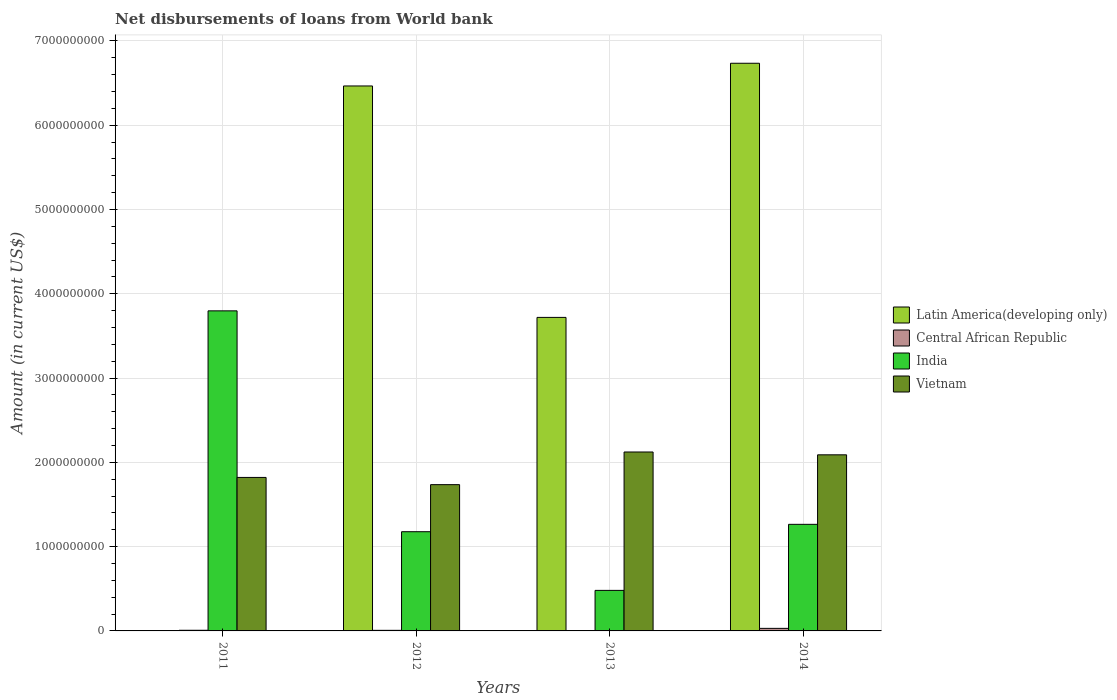How many different coloured bars are there?
Offer a very short reply. 4. How many groups of bars are there?
Make the answer very short. 4. Are the number of bars per tick equal to the number of legend labels?
Provide a short and direct response. No. Are the number of bars on each tick of the X-axis equal?
Provide a short and direct response. No. How many bars are there on the 3rd tick from the left?
Provide a short and direct response. 3. What is the label of the 3rd group of bars from the left?
Provide a succinct answer. 2013. In how many cases, is the number of bars for a given year not equal to the number of legend labels?
Offer a terse response. 2. What is the amount of loan disbursed from World Bank in Vietnam in 2013?
Make the answer very short. 2.12e+09. Across all years, what is the maximum amount of loan disbursed from World Bank in India?
Offer a very short reply. 3.80e+09. Across all years, what is the minimum amount of loan disbursed from World Bank in Central African Republic?
Ensure brevity in your answer.  0. In which year was the amount of loan disbursed from World Bank in Central African Republic maximum?
Ensure brevity in your answer.  2014. What is the total amount of loan disbursed from World Bank in Latin America(developing only) in the graph?
Your answer should be compact. 1.69e+1. What is the difference between the amount of loan disbursed from World Bank in India in 2011 and that in 2013?
Keep it short and to the point. 3.32e+09. What is the difference between the amount of loan disbursed from World Bank in Vietnam in 2014 and the amount of loan disbursed from World Bank in India in 2013?
Make the answer very short. 1.61e+09. What is the average amount of loan disbursed from World Bank in India per year?
Provide a short and direct response. 1.68e+09. In the year 2013, what is the difference between the amount of loan disbursed from World Bank in India and amount of loan disbursed from World Bank in Latin America(developing only)?
Keep it short and to the point. -3.24e+09. What is the ratio of the amount of loan disbursed from World Bank in Latin America(developing only) in 2013 to that in 2014?
Your answer should be very brief. 0.55. What is the difference between the highest and the second highest amount of loan disbursed from World Bank in India?
Make the answer very short. 2.53e+09. What is the difference between the highest and the lowest amount of loan disbursed from World Bank in Central African Republic?
Provide a succinct answer. 3.04e+07. Is the sum of the amount of loan disbursed from World Bank in Central African Republic in 2011 and 2012 greater than the maximum amount of loan disbursed from World Bank in Latin America(developing only) across all years?
Keep it short and to the point. No. Is it the case that in every year, the sum of the amount of loan disbursed from World Bank in Vietnam and amount of loan disbursed from World Bank in Latin America(developing only) is greater than the amount of loan disbursed from World Bank in Central African Republic?
Keep it short and to the point. Yes. How many bars are there?
Ensure brevity in your answer.  14. How many years are there in the graph?
Your answer should be very brief. 4. What is the difference between two consecutive major ticks on the Y-axis?
Offer a terse response. 1.00e+09. How are the legend labels stacked?
Your response must be concise. Vertical. What is the title of the graph?
Make the answer very short. Net disbursements of loans from World bank. Does "Uganda" appear as one of the legend labels in the graph?
Make the answer very short. No. What is the Amount (in current US$) of Central African Republic in 2011?
Provide a short and direct response. 7.68e+06. What is the Amount (in current US$) in India in 2011?
Make the answer very short. 3.80e+09. What is the Amount (in current US$) of Vietnam in 2011?
Your answer should be very brief. 1.82e+09. What is the Amount (in current US$) in Latin America(developing only) in 2012?
Provide a succinct answer. 6.47e+09. What is the Amount (in current US$) in Central African Republic in 2012?
Give a very brief answer. 7.00e+06. What is the Amount (in current US$) in India in 2012?
Provide a succinct answer. 1.18e+09. What is the Amount (in current US$) of Vietnam in 2012?
Provide a short and direct response. 1.74e+09. What is the Amount (in current US$) in Latin America(developing only) in 2013?
Your answer should be very brief. 3.72e+09. What is the Amount (in current US$) in India in 2013?
Offer a terse response. 4.81e+08. What is the Amount (in current US$) of Vietnam in 2013?
Your answer should be compact. 2.12e+09. What is the Amount (in current US$) in Latin America(developing only) in 2014?
Make the answer very short. 6.74e+09. What is the Amount (in current US$) of Central African Republic in 2014?
Offer a terse response. 3.04e+07. What is the Amount (in current US$) in India in 2014?
Keep it short and to the point. 1.26e+09. What is the Amount (in current US$) of Vietnam in 2014?
Provide a succinct answer. 2.09e+09. Across all years, what is the maximum Amount (in current US$) in Latin America(developing only)?
Provide a succinct answer. 6.74e+09. Across all years, what is the maximum Amount (in current US$) in Central African Republic?
Provide a short and direct response. 3.04e+07. Across all years, what is the maximum Amount (in current US$) in India?
Your response must be concise. 3.80e+09. Across all years, what is the maximum Amount (in current US$) of Vietnam?
Your answer should be compact. 2.12e+09. Across all years, what is the minimum Amount (in current US$) in Latin America(developing only)?
Your response must be concise. 0. Across all years, what is the minimum Amount (in current US$) in Central African Republic?
Your response must be concise. 0. Across all years, what is the minimum Amount (in current US$) in India?
Keep it short and to the point. 4.81e+08. Across all years, what is the minimum Amount (in current US$) in Vietnam?
Provide a short and direct response. 1.74e+09. What is the total Amount (in current US$) of Latin America(developing only) in the graph?
Your answer should be very brief. 1.69e+1. What is the total Amount (in current US$) in Central African Republic in the graph?
Your answer should be very brief. 4.51e+07. What is the total Amount (in current US$) in India in the graph?
Your answer should be very brief. 6.72e+09. What is the total Amount (in current US$) of Vietnam in the graph?
Offer a very short reply. 7.77e+09. What is the difference between the Amount (in current US$) in Central African Republic in 2011 and that in 2012?
Provide a short and direct response. 6.77e+05. What is the difference between the Amount (in current US$) of India in 2011 and that in 2012?
Provide a succinct answer. 2.62e+09. What is the difference between the Amount (in current US$) in Vietnam in 2011 and that in 2012?
Keep it short and to the point. 8.57e+07. What is the difference between the Amount (in current US$) in India in 2011 and that in 2013?
Make the answer very short. 3.32e+09. What is the difference between the Amount (in current US$) in Vietnam in 2011 and that in 2013?
Your response must be concise. -3.02e+08. What is the difference between the Amount (in current US$) in Central African Republic in 2011 and that in 2014?
Give a very brief answer. -2.27e+07. What is the difference between the Amount (in current US$) of India in 2011 and that in 2014?
Offer a terse response. 2.53e+09. What is the difference between the Amount (in current US$) of Vietnam in 2011 and that in 2014?
Offer a terse response. -2.68e+08. What is the difference between the Amount (in current US$) in Latin America(developing only) in 2012 and that in 2013?
Your answer should be compact. 2.75e+09. What is the difference between the Amount (in current US$) of India in 2012 and that in 2013?
Your answer should be very brief. 6.96e+08. What is the difference between the Amount (in current US$) in Vietnam in 2012 and that in 2013?
Give a very brief answer. -3.87e+08. What is the difference between the Amount (in current US$) of Latin America(developing only) in 2012 and that in 2014?
Your answer should be very brief. -2.69e+08. What is the difference between the Amount (in current US$) in Central African Republic in 2012 and that in 2014?
Give a very brief answer. -2.34e+07. What is the difference between the Amount (in current US$) in India in 2012 and that in 2014?
Make the answer very short. -8.75e+07. What is the difference between the Amount (in current US$) of Vietnam in 2012 and that in 2014?
Give a very brief answer. -3.54e+08. What is the difference between the Amount (in current US$) of Latin America(developing only) in 2013 and that in 2014?
Your answer should be compact. -3.02e+09. What is the difference between the Amount (in current US$) of India in 2013 and that in 2014?
Give a very brief answer. -7.84e+08. What is the difference between the Amount (in current US$) of Vietnam in 2013 and that in 2014?
Provide a succinct answer. 3.34e+07. What is the difference between the Amount (in current US$) of Central African Republic in 2011 and the Amount (in current US$) of India in 2012?
Provide a short and direct response. -1.17e+09. What is the difference between the Amount (in current US$) in Central African Republic in 2011 and the Amount (in current US$) in Vietnam in 2012?
Keep it short and to the point. -1.73e+09. What is the difference between the Amount (in current US$) of India in 2011 and the Amount (in current US$) of Vietnam in 2012?
Your answer should be very brief. 2.06e+09. What is the difference between the Amount (in current US$) of Central African Republic in 2011 and the Amount (in current US$) of India in 2013?
Make the answer very short. -4.73e+08. What is the difference between the Amount (in current US$) in Central African Republic in 2011 and the Amount (in current US$) in Vietnam in 2013?
Provide a short and direct response. -2.12e+09. What is the difference between the Amount (in current US$) of India in 2011 and the Amount (in current US$) of Vietnam in 2013?
Your response must be concise. 1.67e+09. What is the difference between the Amount (in current US$) in Central African Republic in 2011 and the Amount (in current US$) in India in 2014?
Your response must be concise. -1.26e+09. What is the difference between the Amount (in current US$) in Central African Republic in 2011 and the Amount (in current US$) in Vietnam in 2014?
Your answer should be very brief. -2.08e+09. What is the difference between the Amount (in current US$) of India in 2011 and the Amount (in current US$) of Vietnam in 2014?
Your answer should be compact. 1.71e+09. What is the difference between the Amount (in current US$) of Latin America(developing only) in 2012 and the Amount (in current US$) of India in 2013?
Offer a terse response. 5.99e+09. What is the difference between the Amount (in current US$) of Latin America(developing only) in 2012 and the Amount (in current US$) of Vietnam in 2013?
Provide a succinct answer. 4.34e+09. What is the difference between the Amount (in current US$) in Central African Republic in 2012 and the Amount (in current US$) in India in 2013?
Your answer should be very brief. -4.74e+08. What is the difference between the Amount (in current US$) of Central African Republic in 2012 and the Amount (in current US$) of Vietnam in 2013?
Make the answer very short. -2.12e+09. What is the difference between the Amount (in current US$) in India in 2012 and the Amount (in current US$) in Vietnam in 2013?
Provide a succinct answer. -9.46e+08. What is the difference between the Amount (in current US$) of Latin America(developing only) in 2012 and the Amount (in current US$) of Central African Republic in 2014?
Ensure brevity in your answer.  6.44e+09. What is the difference between the Amount (in current US$) of Latin America(developing only) in 2012 and the Amount (in current US$) of India in 2014?
Your answer should be compact. 5.20e+09. What is the difference between the Amount (in current US$) in Latin America(developing only) in 2012 and the Amount (in current US$) in Vietnam in 2014?
Ensure brevity in your answer.  4.38e+09. What is the difference between the Amount (in current US$) in Central African Republic in 2012 and the Amount (in current US$) in India in 2014?
Your answer should be compact. -1.26e+09. What is the difference between the Amount (in current US$) of Central African Republic in 2012 and the Amount (in current US$) of Vietnam in 2014?
Provide a succinct answer. -2.08e+09. What is the difference between the Amount (in current US$) of India in 2012 and the Amount (in current US$) of Vietnam in 2014?
Your response must be concise. -9.12e+08. What is the difference between the Amount (in current US$) of Latin America(developing only) in 2013 and the Amount (in current US$) of Central African Republic in 2014?
Your response must be concise. 3.69e+09. What is the difference between the Amount (in current US$) of Latin America(developing only) in 2013 and the Amount (in current US$) of India in 2014?
Your answer should be very brief. 2.46e+09. What is the difference between the Amount (in current US$) of Latin America(developing only) in 2013 and the Amount (in current US$) of Vietnam in 2014?
Your answer should be very brief. 1.63e+09. What is the difference between the Amount (in current US$) in India in 2013 and the Amount (in current US$) in Vietnam in 2014?
Keep it short and to the point. -1.61e+09. What is the average Amount (in current US$) in Latin America(developing only) per year?
Offer a terse response. 4.23e+09. What is the average Amount (in current US$) of Central African Republic per year?
Your response must be concise. 1.13e+07. What is the average Amount (in current US$) of India per year?
Provide a short and direct response. 1.68e+09. What is the average Amount (in current US$) of Vietnam per year?
Provide a succinct answer. 1.94e+09. In the year 2011, what is the difference between the Amount (in current US$) in Central African Republic and Amount (in current US$) in India?
Your answer should be compact. -3.79e+09. In the year 2011, what is the difference between the Amount (in current US$) in Central African Republic and Amount (in current US$) in Vietnam?
Your answer should be compact. -1.81e+09. In the year 2011, what is the difference between the Amount (in current US$) of India and Amount (in current US$) of Vietnam?
Offer a terse response. 1.98e+09. In the year 2012, what is the difference between the Amount (in current US$) in Latin America(developing only) and Amount (in current US$) in Central African Republic?
Make the answer very short. 6.46e+09. In the year 2012, what is the difference between the Amount (in current US$) in Latin America(developing only) and Amount (in current US$) in India?
Provide a succinct answer. 5.29e+09. In the year 2012, what is the difference between the Amount (in current US$) of Latin America(developing only) and Amount (in current US$) of Vietnam?
Offer a very short reply. 4.73e+09. In the year 2012, what is the difference between the Amount (in current US$) of Central African Republic and Amount (in current US$) of India?
Provide a short and direct response. -1.17e+09. In the year 2012, what is the difference between the Amount (in current US$) of Central African Republic and Amount (in current US$) of Vietnam?
Your answer should be very brief. -1.73e+09. In the year 2012, what is the difference between the Amount (in current US$) of India and Amount (in current US$) of Vietnam?
Your answer should be very brief. -5.58e+08. In the year 2013, what is the difference between the Amount (in current US$) of Latin America(developing only) and Amount (in current US$) of India?
Your response must be concise. 3.24e+09. In the year 2013, what is the difference between the Amount (in current US$) of Latin America(developing only) and Amount (in current US$) of Vietnam?
Provide a short and direct response. 1.60e+09. In the year 2013, what is the difference between the Amount (in current US$) in India and Amount (in current US$) in Vietnam?
Ensure brevity in your answer.  -1.64e+09. In the year 2014, what is the difference between the Amount (in current US$) of Latin America(developing only) and Amount (in current US$) of Central African Republic?
Ensure brevity in your answer.  6.70e+09. In the year 2014, what is the difference between the Amount (in current US$) in Latin America(developing only) and Amount (in current US$) in India?
Provide a short and direct response. 5.47e+09. In the year 2014, what is the difference between the Amount (in current US$) in Latin America(developing only) and Amount (in current US$) in Vietnam?
Ensure brevity in your answer.  4.65e+09. In the year 2014, what is the difference between the Amount (in current US$) in Central African Republic and Amount (in current US$) in India?
Give a very brief answer. -1.23e+09. In the year 2014, what is the difference between the Amount (in current US$) of Central African Republic and Amount (in current US$) of Vietnam?
Make the answer very short. -2.06e+09. In the year 2014, what is the difference between the Amount (in current US$) of India and Amount (in current US$) of Vietnam?
Give a very brief answer. -8.25e+08. What is the ratio of the Amount (in current US$) of Central African Republic in 2011 to that in 2012?
Your answer should be compact. 1.1. What is the ratio of the Amount (in current US$) in India in 2011 to that in 2012?
Offer a terse response. 3.23. What is the ratio of the Amount (in current US$) in Vietnam in 2011 to that in 2012?
Your answer should be very brief. 1.05. What is the ratio of the Amount (in current US$) in India in 2011 to that in 2013?
Your answer should be compact. 7.89. What is the ratio of the Amount (in current US$) of Vietnam in 2011 to that in 2013?
Give a very brief answer. 0.86. What is the ratio of the Amount (in current US$) in Central African Republic in 2011 to that in 2014?
Offer a very short reply. 0.25. What is the ratio of the Amount (in current US$) of India in 2011 to that in 2014?
Ensure brevity in your answer.  3. What is the ratio of the Amount (in current US$) of Vietnam in 2011 to that in 2014?
Ensure brevity in your answer.  0.87. What is the ratio of the Amount (in current US$) in Latin America(developing only) in 2012 to that in 2013?
Offer a terse response. 1.74. What is the ratio of the Amount (in current US$) of India in 2012 to that in 2013?
Your response must be concise. 2.45. What is the ratio of the Amount (in current US$) in Vietnam in 2012 to that in 2013?
Your response must be concise. 0.82. What is the ratio of the Amount (in current US$) in Latin America(developing only) in 2012 to that in 2014?
Ensure brevity in your answer.  0.96. What is the ratio of the Amount (in current US$) of Central African Republic in 2012 to that in 2014?
Make the answer very short. 0.23. What is the ratio of the Amount (in current US$) of India in 2012 to that in 2014?
Make the answer very short. 0.93. What is the ratio of the Amount (in current US$) of Vietnam in 2012 to that in 2014?
Ensure brevity in your answer.  0.83. What is the ratio of the Amount (in current US$) in Latin America(developing only) in 2013 to that in 2014?
Ensure brevity in your answer.  0.55. What is the ratio of the Amount (in current US$) in India in 2013 to that in 2014?
Make the answer very short. 0.38. What is the difference between the highest and the second highest Amount (in current US$) in Latin America(developing only)?
Keep it short and to the point. 2.69e+08. What is the difference between the highest and the second highest Amount (in current US$) of Central African Republic?
Keep it short and to the point. 2.27e+07. What is the difference between the highest and the second highest Amount (in current US$) of India?
Ensure brevity in your answer.  2.53e+09. What is the difference between the highest and the second highest Amount (in current US$) of Vietnam?
Your response must be concise. 3.34e+07. What is the difference between the highest and the lowest Amount (in current US$) in Latin America(developing only)?
Your response must be concise. 6.74e+09. What is the difference between the highest and the lowest Amount (in current US$) in Central African Republic?
Ensure brevity in your answer.  3.04e+07. What is the difference between the highest and the lowest Amount (in current US$) of India?
Offer a terse response. 3.32e+09. What is the difference between the highest and the lowest Amount (in current US$) in Vietnam?
Your answer should be compact. 3.87e+08. 